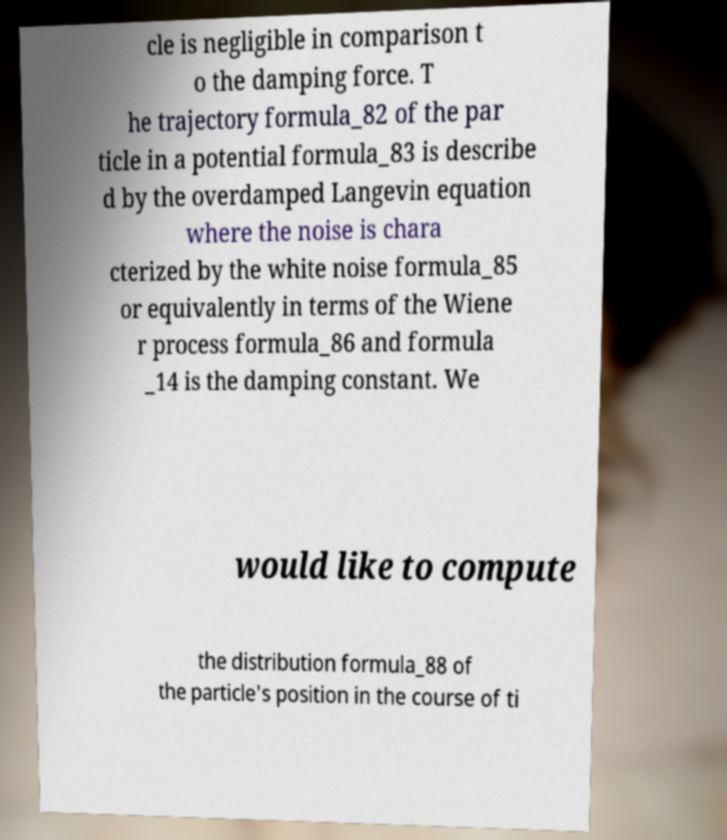Can you accurately transcribe the text from the provided image for me? cle is negligible in comparison t o the damping force. T he trajectory formula_82 of the par ticle in a potential formula_83 is describe d by the overdamped Langevin equation where the noise is chara cterized by the white noise formula_85 or equivalently in terms of the Wiene r process formula_86 and formula _14 is the damping constant. We would like to compute the distribution formula_88 of the particle's position in the course of ti 